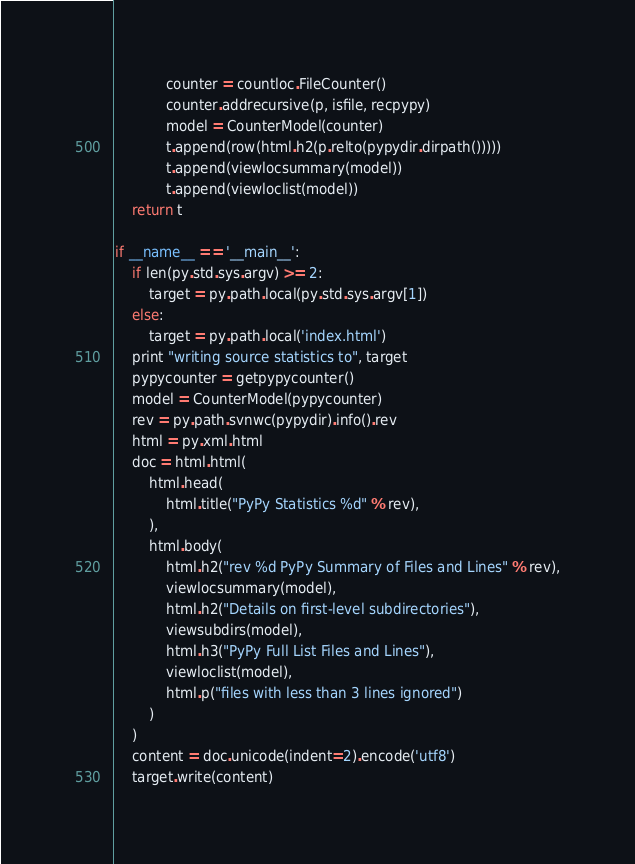<code> <loc_0><loc_0><loc_500><loc_500><_Python_>            counter = countloc.FileCounter()
            counter.addrecursive(p, isfile, recpypy)
            model = CounterModel(counter)
            t.append(row(html.h2(p.relto(pypydir.dirpath()))))
            t.append(viewlocsummary(model))
            t.append(viewloclist(model))
    return t

if __name__ == '__main__':
    if len(py.std.sys.argv) >= 2:
        target = py.path.local(py.std.sys.argv[1])
    else:
        target = py.path.local('index.html')
    print "writing source statistics to", target
    pypycounter = getpypycounter()
    model = CounterModel(pypycounter)
    rev = py.path.svnwc(pypydir).info().rev
    html = py.xml.html
    doc = html.html(
        html.head(
            html.title("PyPy Statistics %d" % rev),
        ),
        html.body(
            html.h2("rev %d PyPy Summary of Files and Lines" % rev),
            viewlocsummary(model),
            html.h2("Details on first-level subdirectories"),
            viewsubdirs(model),
            html.h3("PyPy Full List Files and Lines"),
            viewloclist(model),
            html.p("files with less than 3 lines ignored")
        )
    )
    content = doc.unicode(indent=2).encode('utf8')
    target.write(content)
</code> 